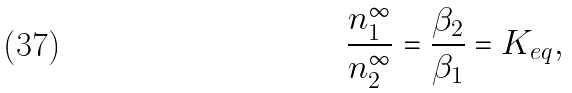Convert formula to latex. <formula><loc_0><loc_0><loc_500><loc_500>\frac { n _ { 1 } ^ { \infty } } { n _ { 2 } ^ { \infty } } = \frac { \beta _ { 2 } } { \beta _ { 1 } } = K _ { e q } ,</formula> 